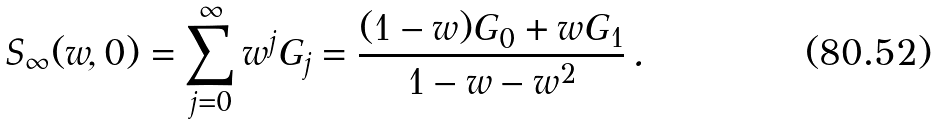Convert formula to latex. <formula><loc_0><loc_0><loc_500><loc_500>S _ { \infty } ( w , 0 ) = \sum _ { j = 0 } ^ { \infty } { w ^ { j } G _ { j } } = \frac { ( 1 - w ) G _ { 0 } + w G _ { 1 } } { 1 - w - w ^ { 2 } } \, .</formula> 